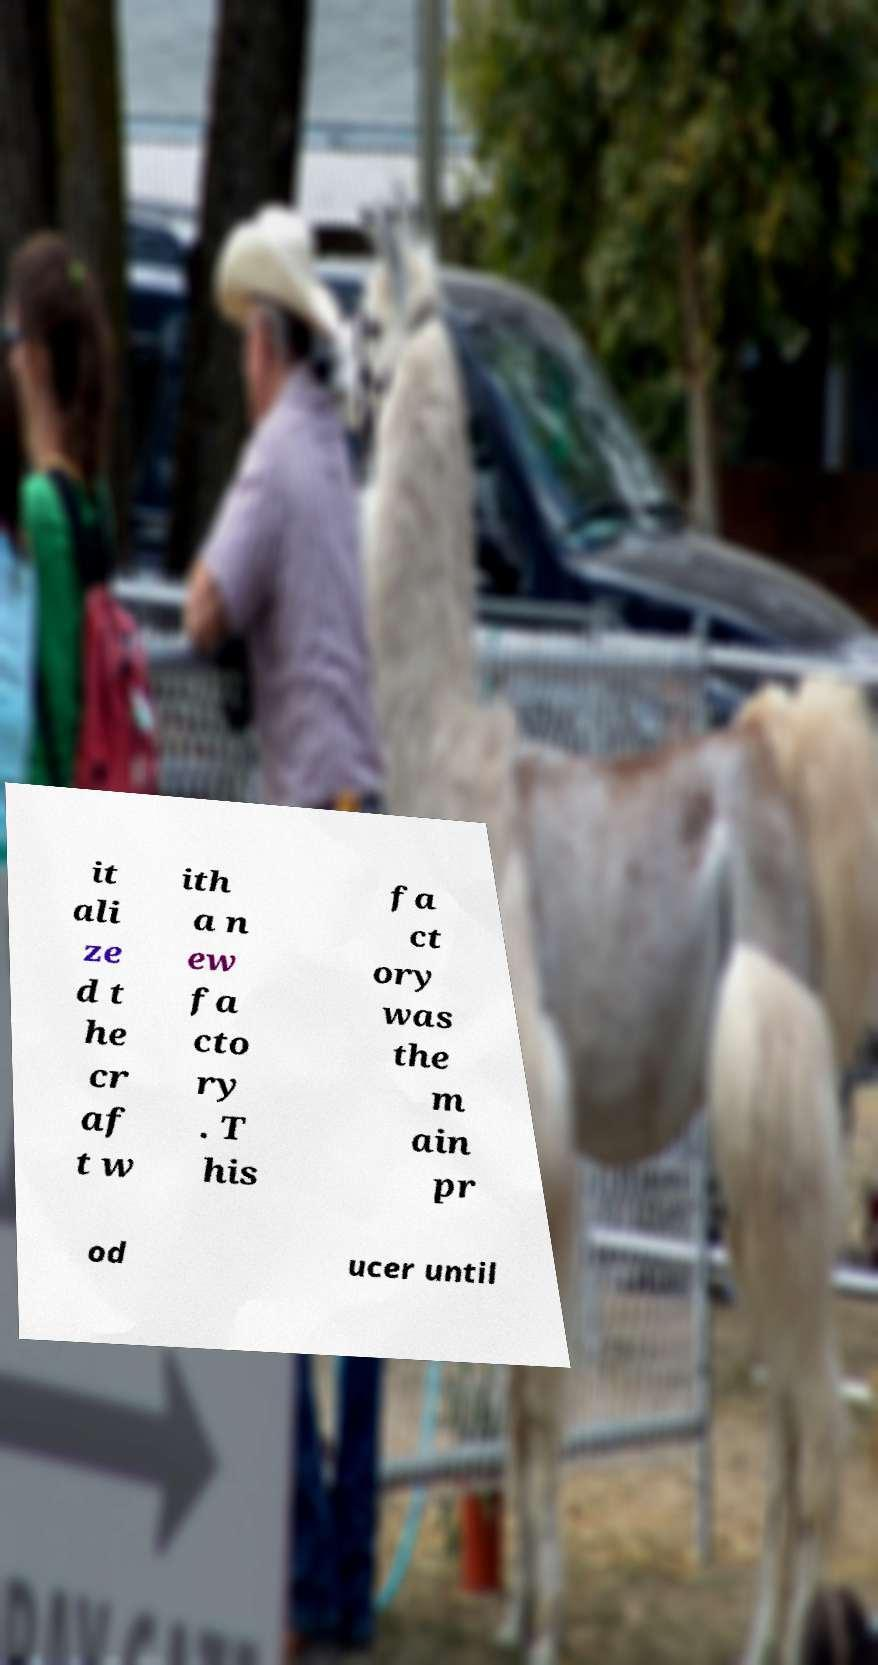Could you extract and type out the text from this image? it ali ze d t he cr af t w ith a n ew fa cto ry . T his fa ct ory was the m ain pr od ucer until 